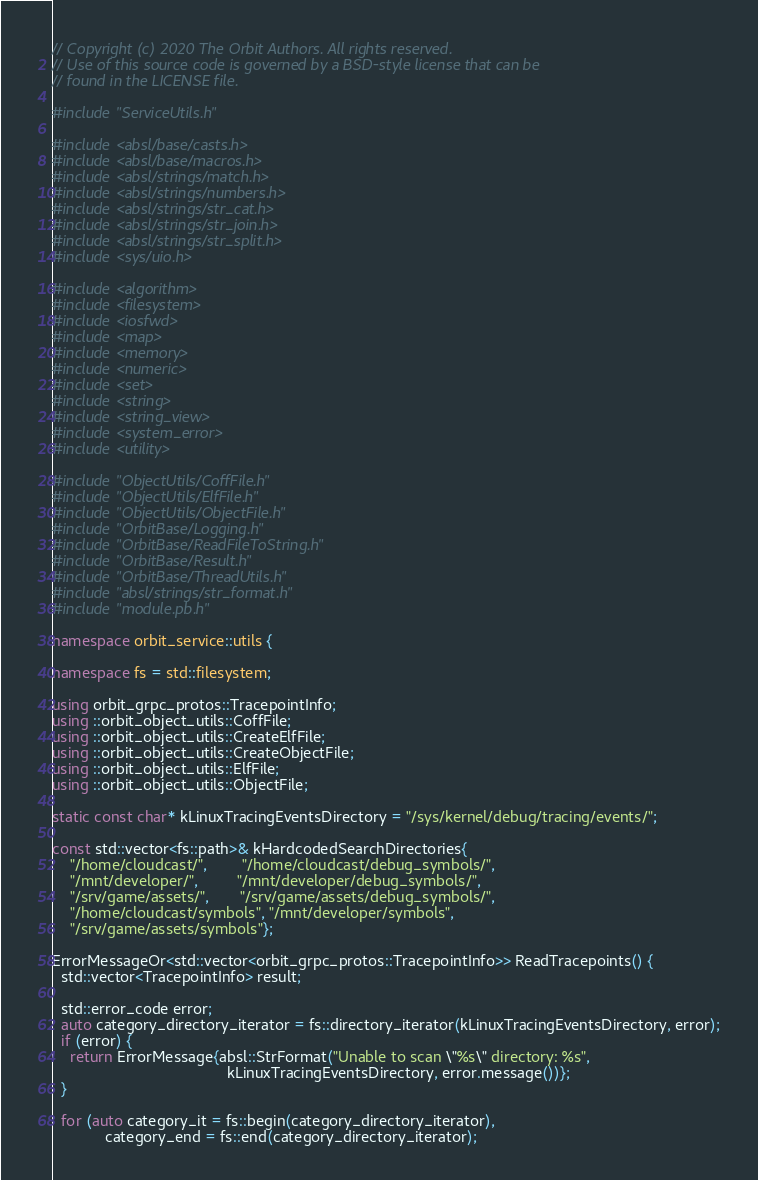Convert code to text. <code><loc_0><loc_0><loc_500><loc_500><_C++_>// Copyright (c) 2020 The Orbit Authors. All rights reserved.
// Use of this source code is governed by a BSD-style license that can be
// found in the LICENSE file.

#include "ServiceUtils.h"

#include <absl/base/casts.h>
#include <absl/base/macros.h>
#include <absl/strings/match.h>
#include <absl/strings/numbers.h>
#include <absl/strings/str_cat.h>
#include <absl/strings/str_join.h>
#include <absl/strings/str_split.h>
#include <sys/uio.h>

#include <algorithm>
#include <filesystem>
#include <iosfwd>
#include <map>
#include <memory>
#include <numeric>
#include <set>
#include <string>
#include <string_view>
#include <system_error>
#include <utility>

#include "ObjectUtils/CoffFile.h"
#include "ObjectUtils/ElfFile.h"
#include "ObjectUtils/ObjectFile.h"
#include "OrbitBase/Logging.h"
#include "OrbitBase/ReadFileToString.h"
#include "OrbitBase/Result.h"
#include "OrbitBase/ThreadUtils.h"
#include "absl/strings/str_format.h"
#include "module.pb.h"

namespace orbit_service::utils {

namespace fs = std::filesystem;

using orbit_grpc_protos::TracepointInfo;
using ::orbit_object_utils::CoffFile;
using ::orbit_object_utils::CreateElfFile;
using ::orbit_object_utils::CreateObjectFile;
using ::orbit_object_utils::ElfFile;
using ::orbit_object_utils::ObjectFile;

static const char* kLinuxTracingEventsDirectory = "/sys/kernel/debug/tracing/events/";

const std::vector<fs::path>& kHardcodedSearchDirectories{
    "/home/cloudcast/",        "/home/cloudcast/debug_symbols/",
    "/mnt/developer/",         "/mnt/developer/debug_symbols/",
    "/srv/game/assets/",       "/srv/game/assets/debug_symbols/",
    "/home/cloudcast/symbols", "/mnt/developer/symbols",
    "/srv/game/assets/symbols"};

ErrorMessageOr<std::vector<orbit_grpc_protos::TracepointInfo>> ReadTracepoints() {
  std::vector<TracepointInfo> result;

  std::error_code error;
  auto category_directory_iterator = fs::directory_iterator(kLinuxTracingEventsDirectory, error);
  if (error) {
    return ErrorMessage{absl::StrFormat("Unable to scan \"%s\" directory: %s",
                                        kLinuxTracingEventsDirectory, error.message())};
  }

  for (auto category_it = fs::begin(category_directory_iterator),
            category_end = fs::end(category_directory_iterator);</code> 